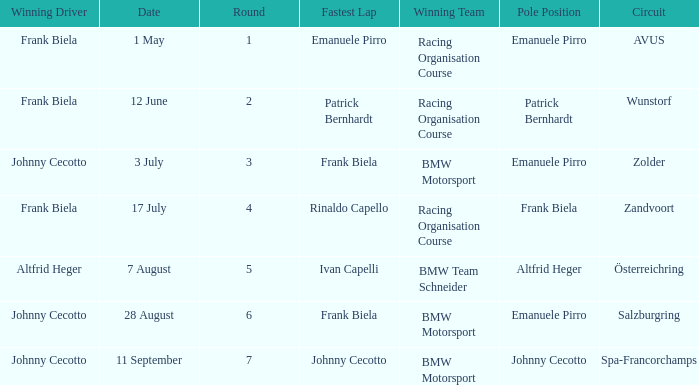Who had pole position in round 7? Johnny Cecotto. 